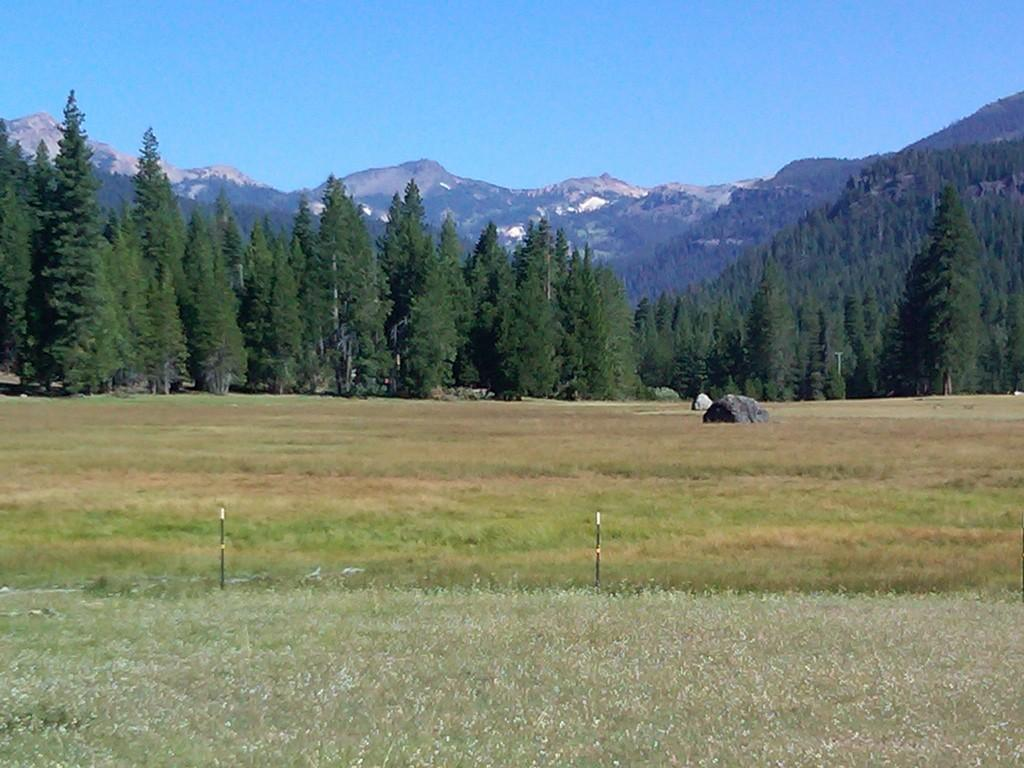What type of vegetation can be seen in the image? There is grass visible in the image. What can be seen in the background of the image? There are trees and hills in the background of the image. What is visible in the sky in the image? The sky is visible in the background of the image. How many kittens can be seen playing in the wilderness in the image? There are no kittens present in the image, and the image does not depict a wilderness setting. 